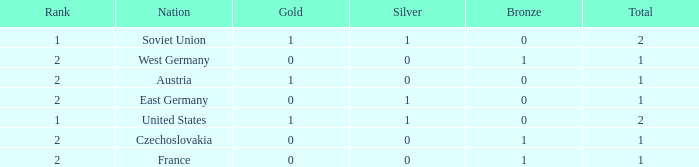What is the total number of bronze medals of West Germany, which is ranked 2 and has less than 1 total medals? 0.0. 